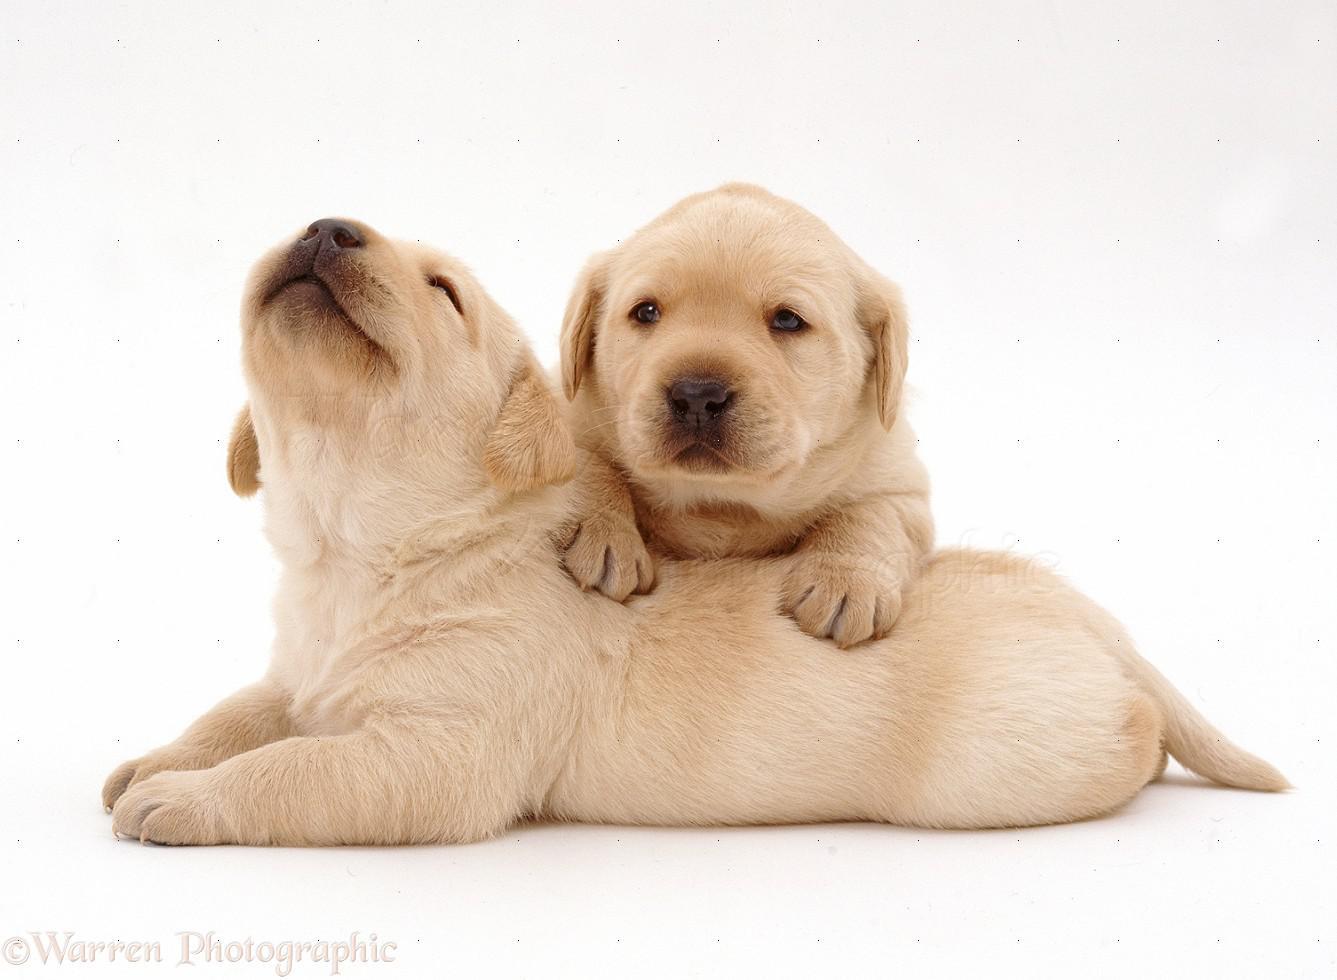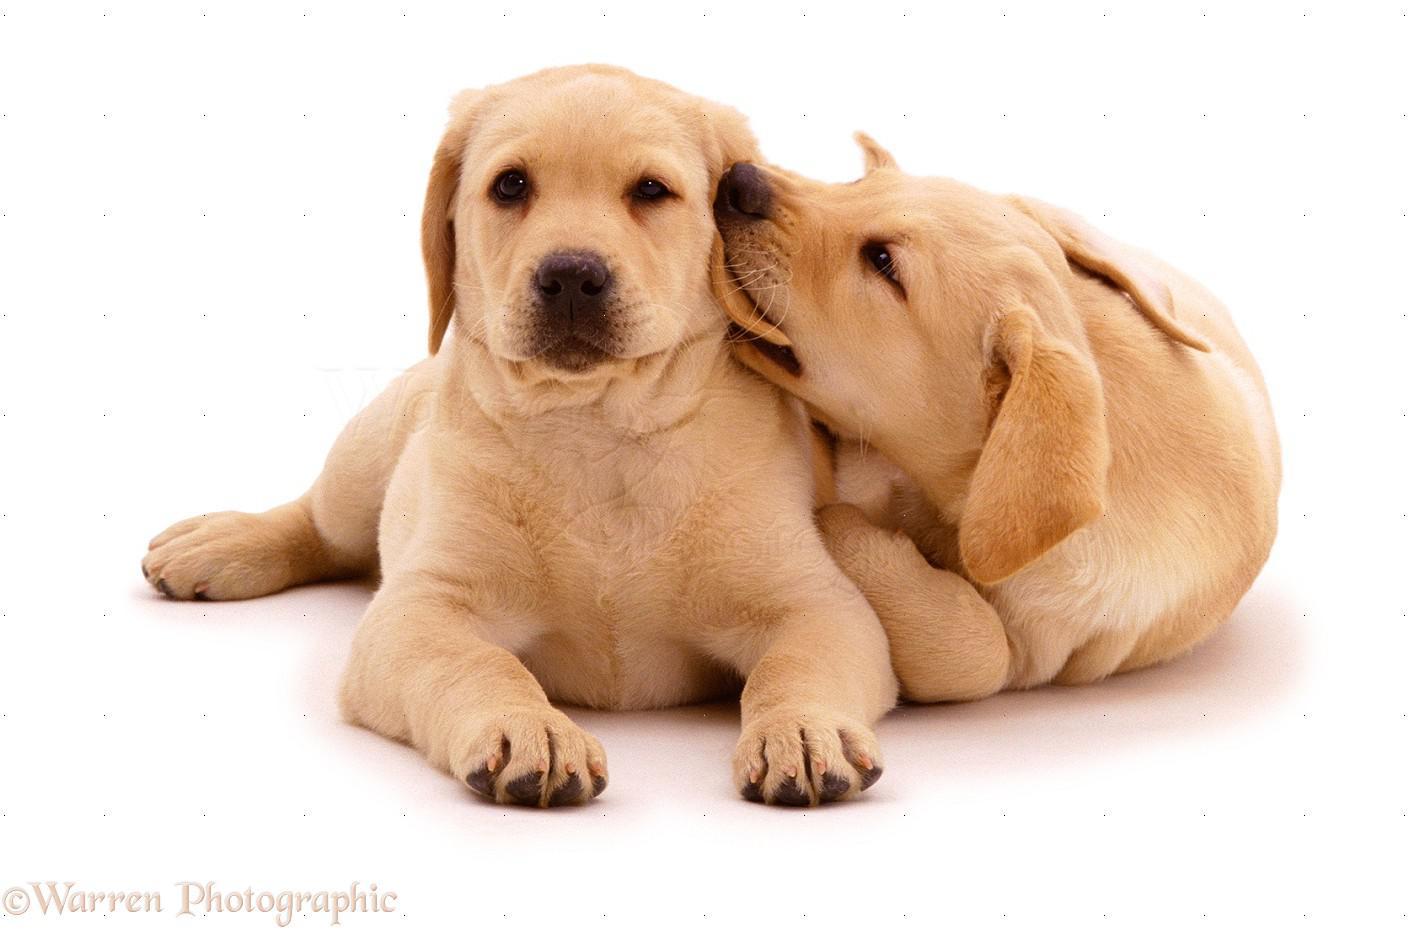The first image is the image on the left, the second image is the image on the right. For the images shown, is this caption "All dogs are puppies with light-colored fur, and each image features a pair of puppies posed close together." true? Answer yes or no. Yes. The first image is the image on the left, the second image is the image on the right. For the images displayed, is the sentence "There are 4 puppies." factually correct? Answer yes or no. Yes. 